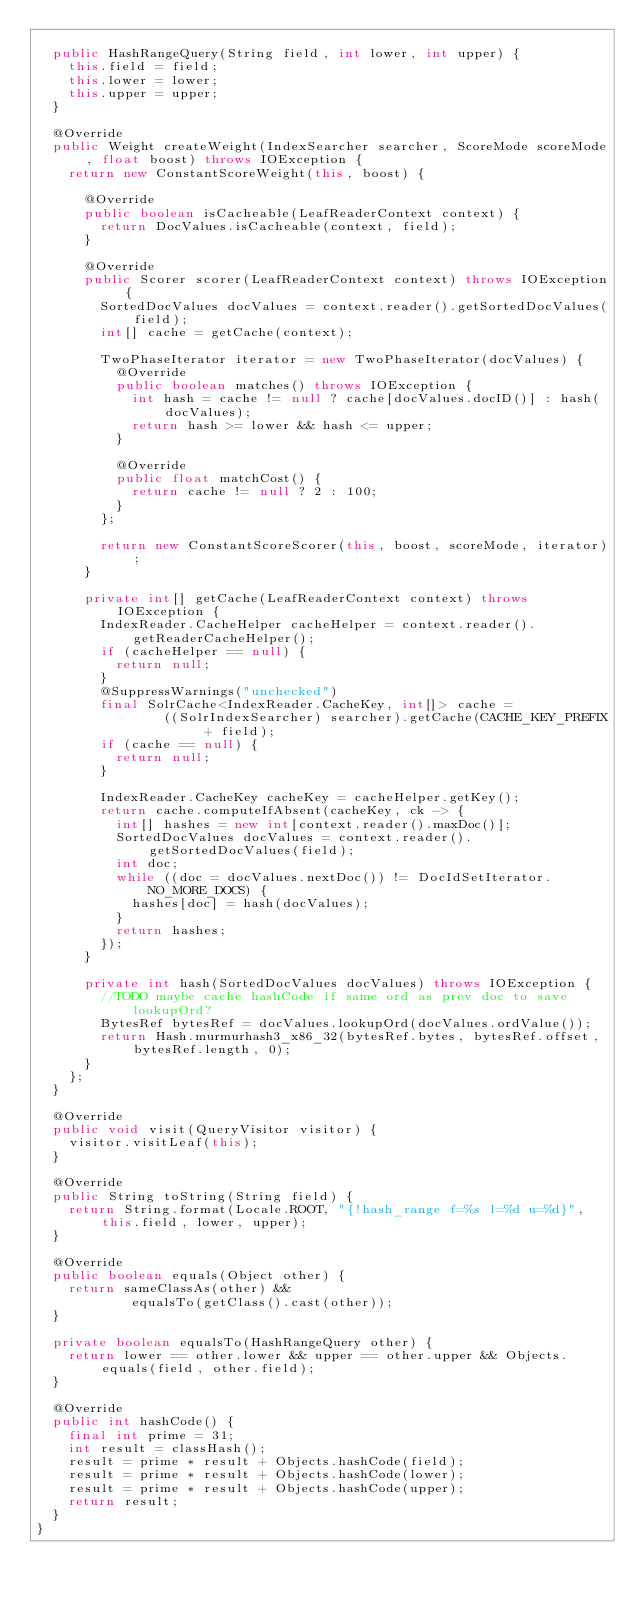<code> <loc_0><loc_0><loc_500><loc_500><_Java_>
  public HashRangeQuery(String field, int lower, int upper) {
    this.field = field;
    this.lower = lower;
    this.upper = upper;
  }

  @Override
  public Weight createWeight(IndexSearcher searcher, ScoreMode scoreMode, float boost) throws IOException {
    return new ConstantScoreWeight(this, boost) {

      @Override
      public boolean isCacheable(LeafReaderContext context) {
        return DocValues.isCacheable(context, field);
      }

      @Override
      public Scorer scorer(LeafReaderContext context) throws IOException {
        SortedDocValues docValues = context.reader().getSortedDocValues(field);
        int[] cache = getCache(context);

        TwoPhaseIterator iterator = new TwoPhaseIterator(docValues) {
          @Override
          public boolean matches() throws IOException {
            int hash = cache != null ? cache[docValues.docID()] : hash(docValues);
            return hash >= lower && hash <= upper;
          }

          @Override
          public float matchCost() {
            return cache != null ? 2 : 100;
          }
        };

        return new ConstantScoreScorer(this, boost, scoreMode, iterator);
      }

      private int[] getCache(LeafReaderContext context) throws IOException {
        IndexReader.CacheHelper cacheHelper = context.reader().getReaderCacheHelper();
        if (cacheHelper == null) {
          return null;
        }
        @SuppressWarnings("unchecked")
        final SolrCache<IndexReader.CacheKey, int[]> cache =
                ((SolrIndexSearcher) searcher).getCache(CACHE_KEY_PREFIX + field);
        if (cache == null) {
          return null;
        }

        IndexReader.CacheKey cacheKey = cacheHelper.getKey();
        return cache.computeIfAbsent(cacheKey, ck -> {
          int[] hashes = new int[context.reader().maxDoc()];
          SortedDocValues docValues = context.reader().getSortedDocValues(field);
          int doc;
          while ((doc = docValues.nextDoc()) != DocIdSetIterator.NO_MORE_DOCS) {
            hashes[doc] = hash(docValues);
          }
          return hashes;
        });
      }

      private int hash(SortedDocValues docValues) throws IOException {
        //TODO maybe cache hashCode if same ord as prev doc to save lookupOrd?
        BytesRef bytesRef = docValues.lookupOrd(docValues.ordValue());
        return Hash.murmurhash3_x86_32(bytesRef.bytes, bytesRef.offset, bytesRef.length, 0);
      }
    };
  }

  @Override
  public void visit(QueryVisitor visitor) {
    visitor.visitLeaf(this);
  }

  @Override
  public String toString(String field) {
    return String.format(Locale.ROOT, "{!hash_range f=%s l=%d u=%d}", this.field, lower, upper);
  }

  @Override
  public boolean equals(Object other) {
    return sameClassAs(other) &&
            equalsTo(getClass().cast(other));
  }

  private boolean equalsTo(HashRangeQuery other) {
    return lower == other.lower && upper == other.upper && Objects.equals(field, other.field);
  }

  @Override
  public int hashCode() {
    final int prime = 31;
    int result = classHash();
    result = prime * result + Objects.hashCode(field);
    result = prime * result + Objects.hashCode(lower);
    result = prime * result + Objects.hashCode(upper);
    return result;
  }
}
</code> 